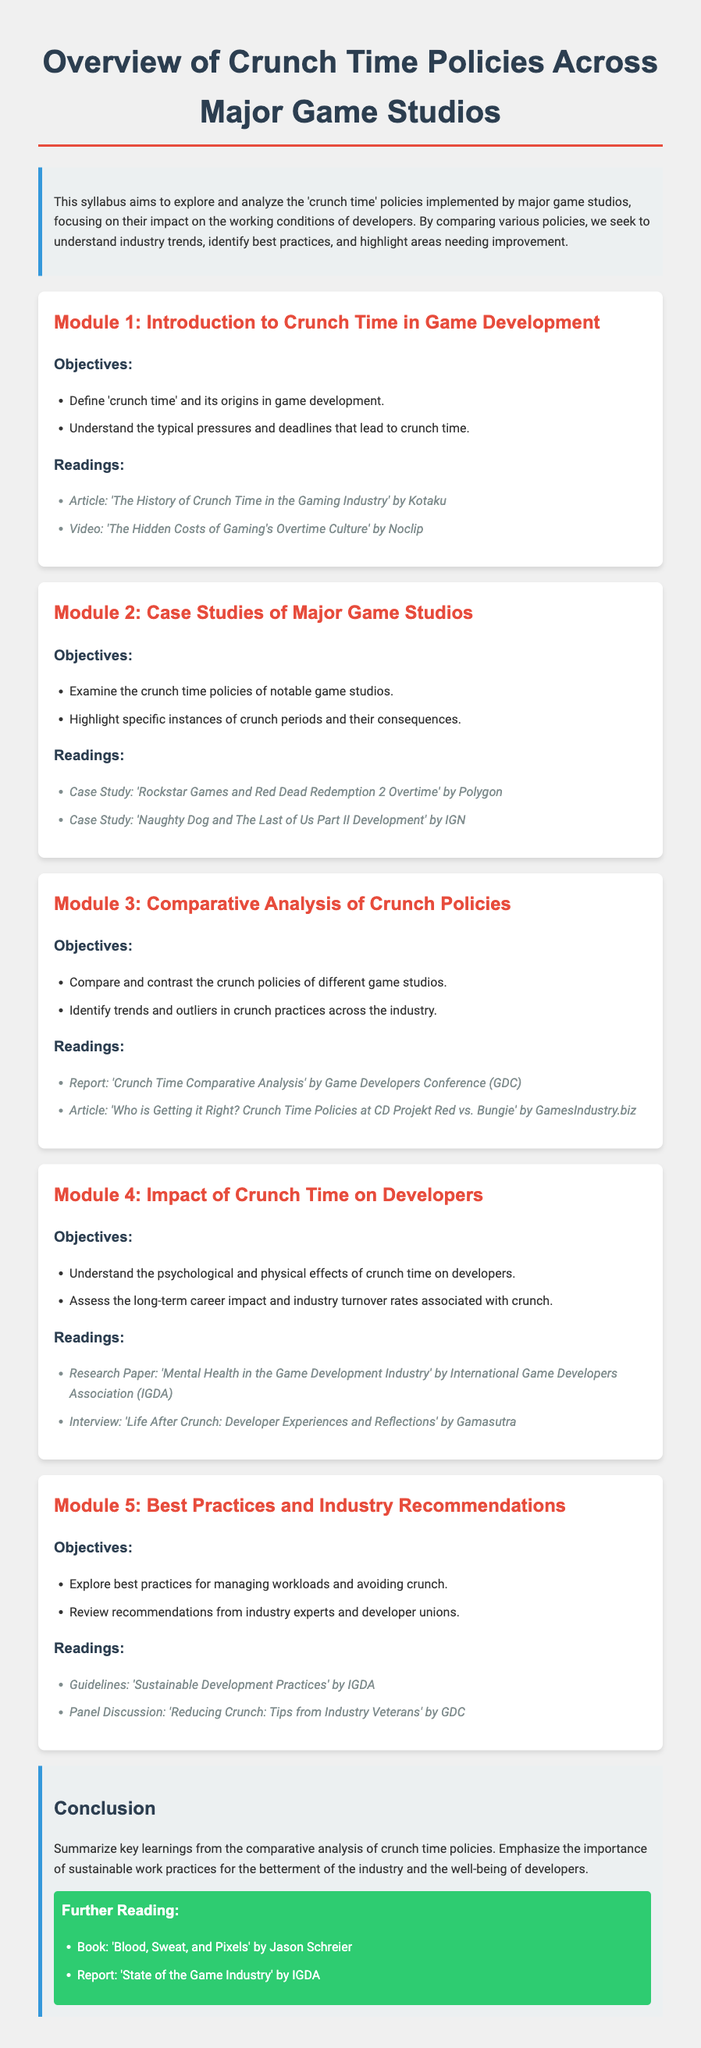what is the title of the syllabus? The title of the syllabus is prominently displayed at the top of the document.
Answer: Overview of Crunch Time Policies Across Major Game Studios how many modules are in the syllabus? Counting the modules listed in the document gives the total number of modules.
Answer: 5 who authored the article 'The History of Crunch Time in the Gaming Industry'? This information can be found in the readings section of Module 1.
Answer: Kotaku what is the aim of the syllabus? The aim is outlined in the introductory paragraph, summarizing the focus of the syllabus.
Answer: Explore and analyze the 'crunch time' policies which game studio's crunch policy is examined in Module 2? This is specified in the objectives of Module 2 where case studies are mentioned.
Answer: Rockstar Games what is a recommended reading at the end of the syllabus? This can be found in the further reading section at the conclusion of the document.
Answer: 'Blood, Sweat, and Pixels' what is one objective of Module 4? The objectives listed for Module 4 provide specific goals for that section.
Answer: Understand the psychological and physical effects of crunch time how does the syllabus categorize the types of questions in the modules? This is implicitly indicated by the structure of each module with objectives and readings.
Answer: Each module includes objectives and readings 